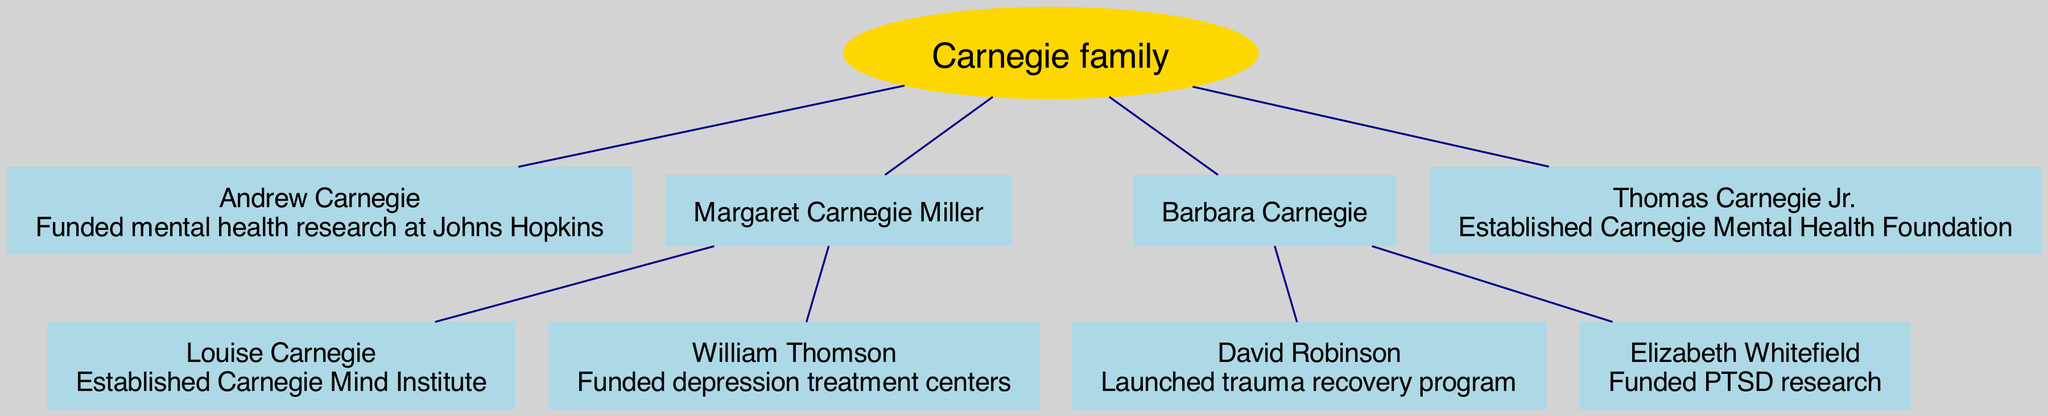What is the name of the root of the family tree? The root of the family tree is labeled as the "Carnegie family." This is the top node and represents the primary lineage from which all other individuals in the diagram descend.
Answer: Carnegie family How many children did Margaret Carnegie Miller have? The diagram shows that Margaret Carnegie Miller had two children: Louise Carnegie and William Thomson. This is identified by looking for her name and noting the children listed under her.
Answer: 2 Who established the Carnegie Mind Institute? Louise Carnegie, the daughter of Margaret Carnegie Miller, is credited with establishing the Carnegie Mind Institute. This is found by tracing the lineage back to Margaret Carnegie Miller and then identifying her child, Louise.
Answer: Louise Carnegie What contribution did David Robinson make? David Robinson is shown as having launched a trauma recovery program. This information is located within the node that represents him in the diagram.
Answer: Launched trauma recovery program Which family member founded the Carnegie Mental Health Foundation? Thomas Carnegie Jr. is identified as the founder of the Carnegie Mental Health Foundation. He is at a different generational level compared to some others, but his contribution is clearly stated in his node.
Answer: Thomas Carnegie Jr Who funded PTSD research? Elizabeth Whitefield, a child of Barbara Carnegie, is associated with funding PTSD research. This can be determined by locating Barbara Carnegie in the tree and finding her child with that contribution.
Answer: Elizabeth Whitefield Which member of the family tree made a contribution related to depression treatment centers? William Thomson, who is a child of Margaret Carnegie Miller, funded depression treatment centers. This is indicated within his node in the diagram.
Answer: William Thomson How many total generations are shown in the family tree? The tree illustrates a total of four generations, starting with the root Carnegie family, followed by Andrew Carnegie and other members. Counting each distinct generational node reveals this number.
Answer: 4 Which two individuals are siblings in the Carnegie family tree? Louise Carnegie and William Thomson are identified as siblings as they are both children of Margaret Carnegie Miller. This relationship is established by their connection to the same parent node.
Answer: Louise Carnegie and William Thomson 